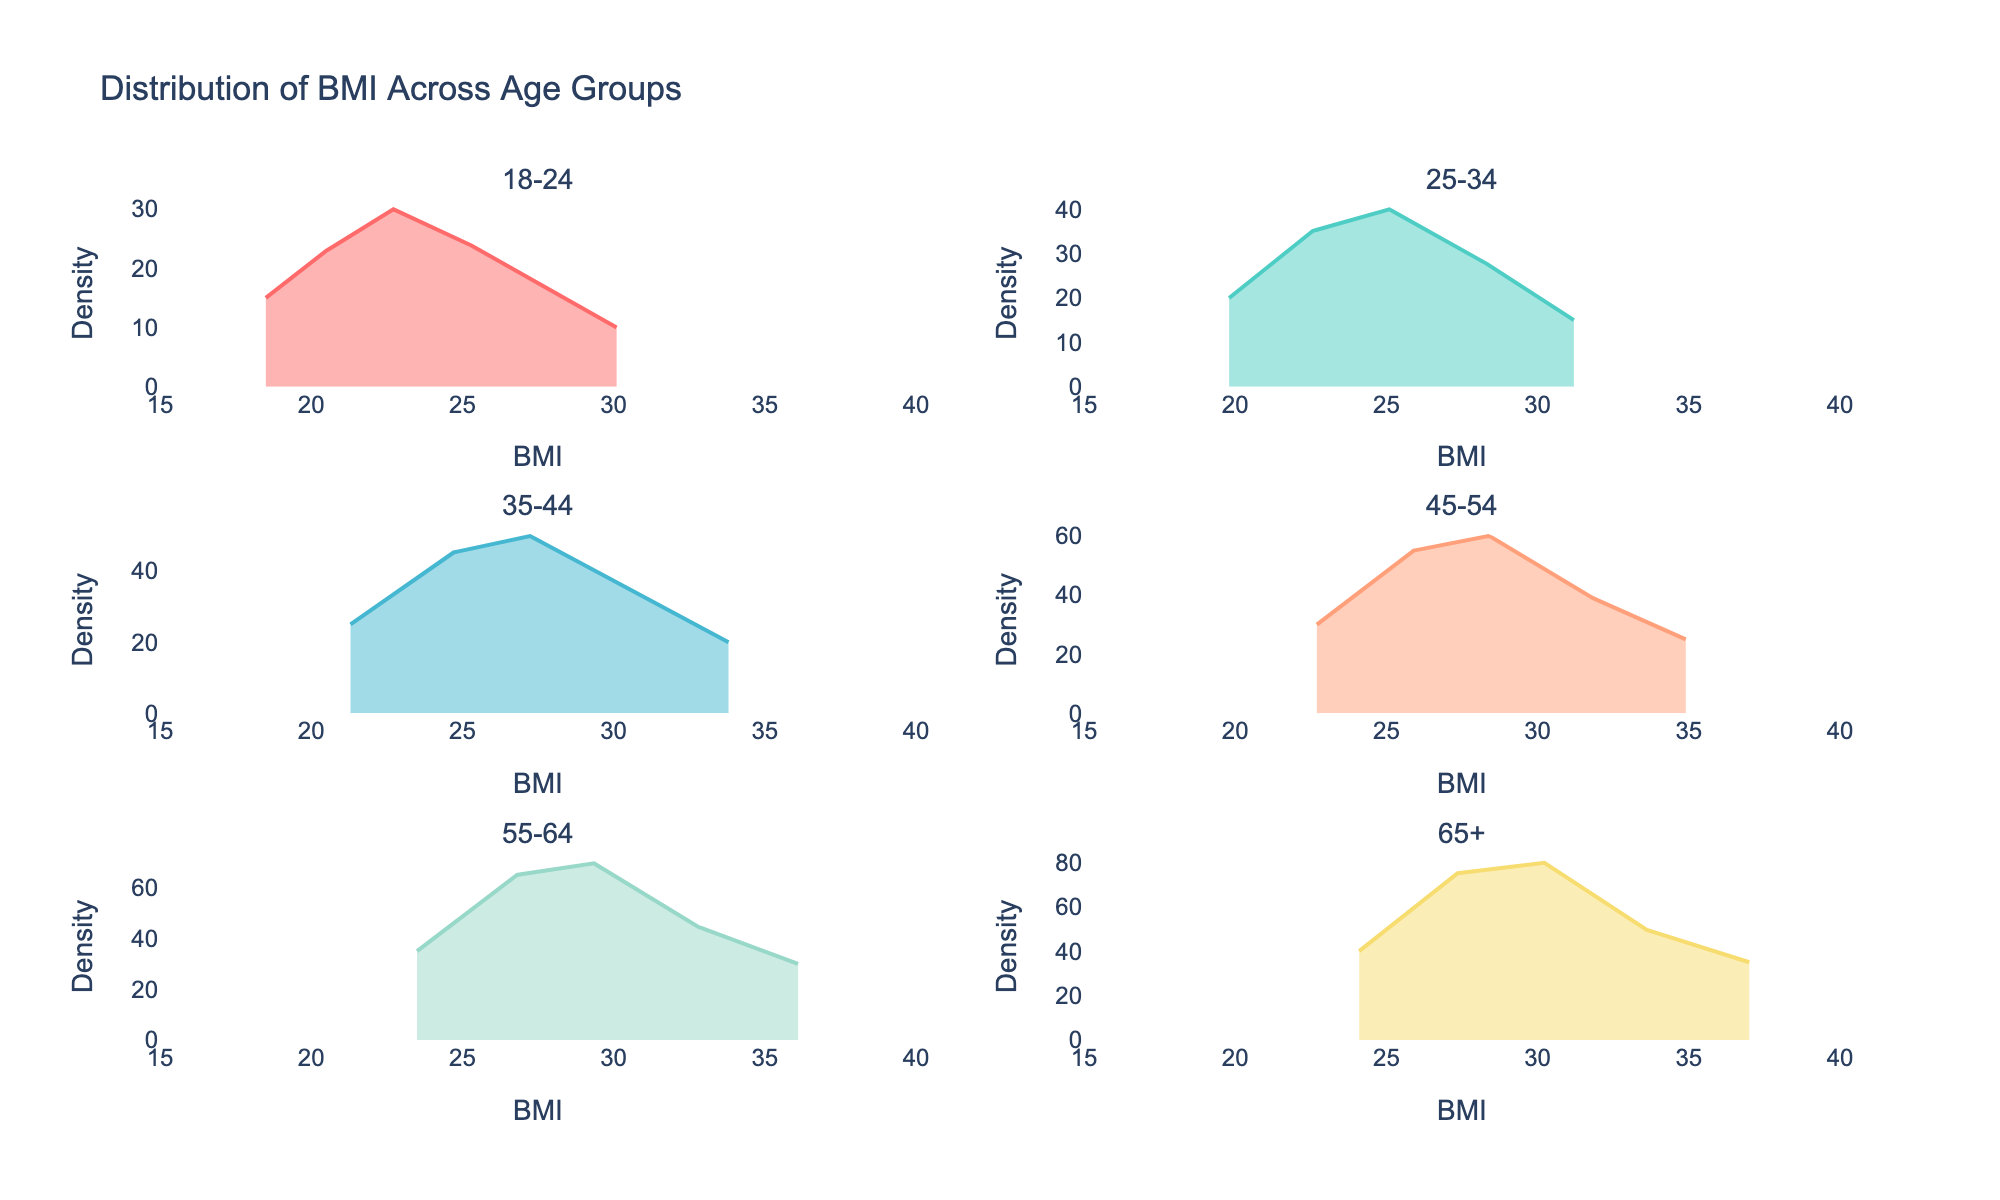What is the title of the figure? The title of the figure is displayed prominently at the top of the plot. Reading the title directly from the figure, it states "Distribution of BMI Across Age Groups".
Answer: Distribution of BMI Across Age Groups How many age groups are shown in the figure? The subplot titles each represent a different age group. Counting these titles in the figure reveals there are six different age groups.
Answer: Six Which age group appears to have the highest BMI density peak? Examining each subplot, we identify the curve that reaches the highest density peak. For the age group 65+, it can be observed that the curve achieves the highest density.
Answer: 65+ What is the range of BMI values displayed on the x-axis? Viewing the x-axis across the subplots, the minimum and maximum values of the BMI range can be noted from the axis labels. The range extends from 15 to 40.
Answer: 15 to 40 In the subplot for the age group 18-24, what is the approximate density peak value? Observing the density curve in the subplot for the age group 18-24, its peak value around BMI 22.7 is roughly around the density of 30.
Answer: Approximately 30 How does the peak density of the 35-44 age group compare to that of the 55-64 age group? To compare these two groups, we observe the density peaks for both age groups. The age group 55-64 has a higher peak density than the age group 35-44, indicating a more significant concentration around the peak BMI for 55-64.
Answer: 55-64 age group has a higher peak density Which age group has the broadest spread in the BMI density curves? Examining the widths of the density curves spanning the BMI values helps identify the broadest spread. The age group 65+ exhibits the broadest spread, extending over a larger BMI range.
Answer: 65+ In terms of BMI, which age group has the narrowest range of high-density values? By evaluating the width of the high-density region for each age group, we see that the age group 18-24 has the narrowest range of high-density BMI values.
Answer: 18-24 Is there an age group where the density decreases notably beyond a BMI of 30? Observing where the density curves decline significantly past a BMI of 30, for the age group 45-54, it drops substantially after 30.
Answer: 45-54 